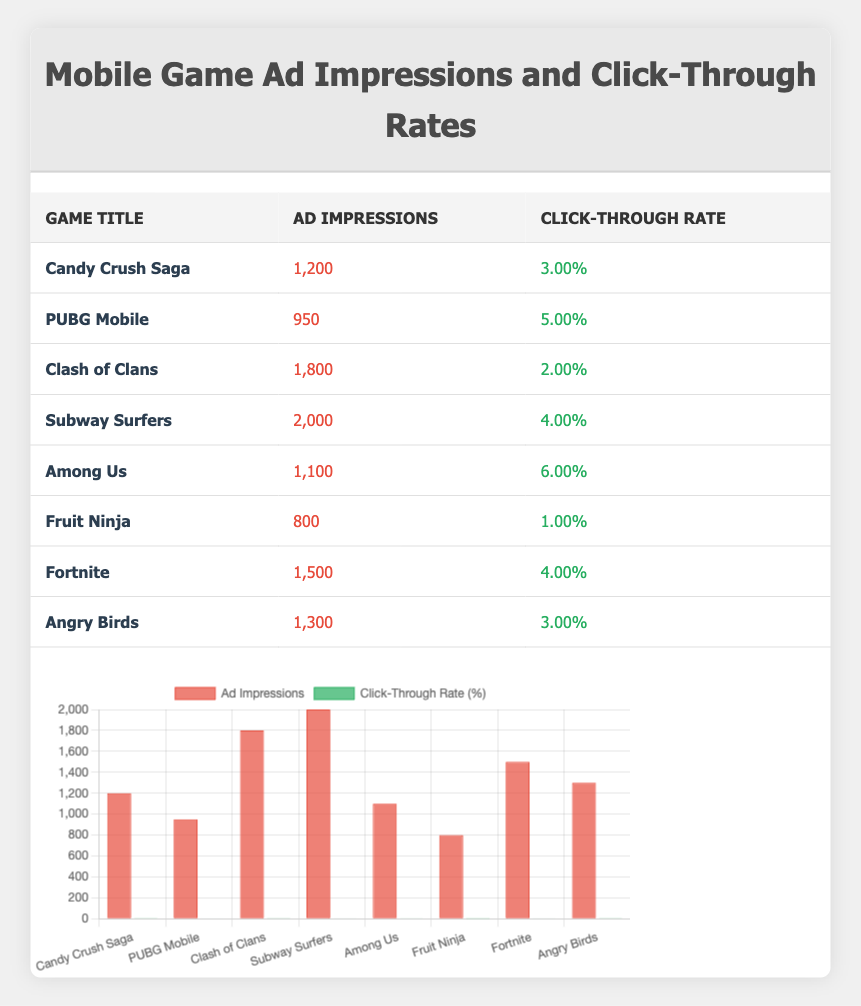What is the game with the highest click-through rate? Among Us has a click-through rate of 6.00%, which is the highest among all the games listed in the table.
Answer: Among Us Which game has the least ad impressions? Fruit Ninja has the least ad impressions with a total of 800, as seen in the Ad Impressions column of the table.
Answer: Fruit Ninja What is the average click-through rate for all games listed? To find the average click-through rate, sum all the rates: (3 + 5 + 2 + 4 + 6 + 1 + 4 + 3) = 28. There are 8 games, so the average is 28/8 = 3.5.
Answer: 3.5 Is there a game that has over 1,500 ad impressions but below a 4% click-through rate? Fortnite has 1,500 ad impressions and a 4% click-through rate, which meets the condition of having over 1,500 impressions but it is not below 4%. Therefore, the answer is no.
Answer: No What is the total number of ad impressions for all games in the table? Adding the ad impressions together gives: 1200 + 950 + 1800 + 2000 + 1100 + 800 + 1500 + 1300 = 10,650.
Answer: 10650 Which game has a similar click-through rate to Candy Crush Saga? Candy Crush Saga has a click-through rate of 3.00%. Angry Birds also has a click-through rate of 3.00%, making it similar.
Answer: Angry Birds Is the click-through rate for Subway Surfers higher than that of Clash of Clans? Subway Surfers has a click-through rate of 4.00% and Clash of Clans has 2.00%. Since 4.00% is higher than 2.00%, the answer is yes.
Answer: Yes What is the difference in ad impressions between the game with the highest and lowest impressions? The game with the highest impressions is Subway Surfers with 2,000, and the lowest is Fruit Ninja with 800. The difference is 2000 - 800 = 1200.
Answer: 1200 